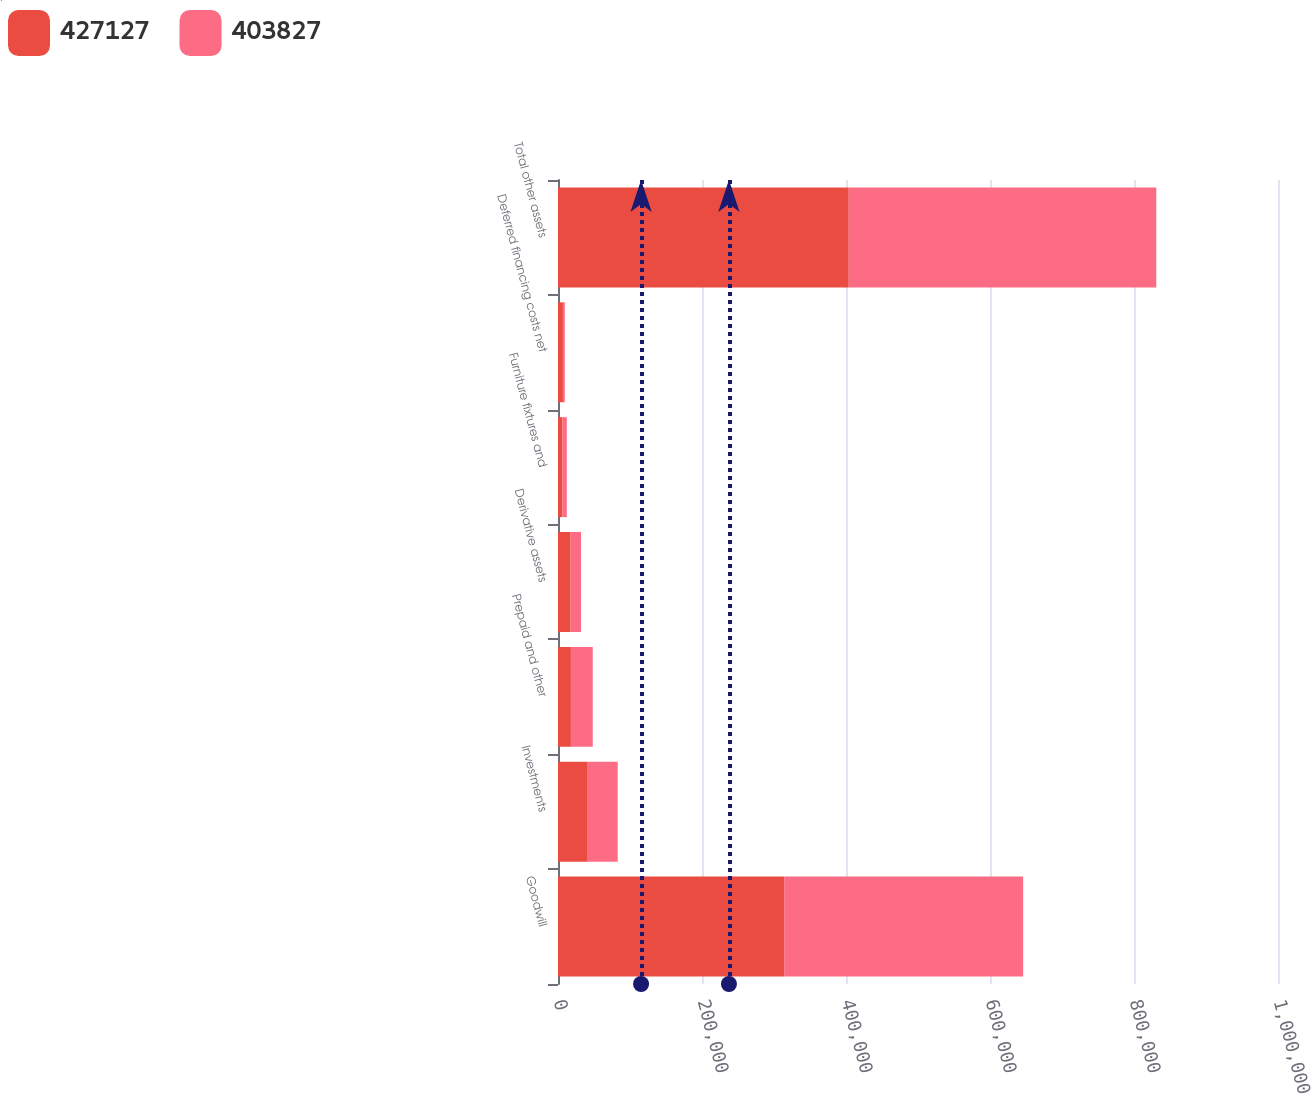Convert chart. <chart><loc_0><loc_0><loc_500><loc_500><stacked_bar_chart><ecel><fcel>Goodwill<fcel>Investments<fcel>Prepaid and other<fcel>Derivative assets<fcel>Furniture fixtures and<fcel>Deferred financing costs net<fcel>Total other assets<nl><fcel>427127<fcel>314143<fcel>41287<fcel>17937<fcel>17482<fcel>6127<fcel>6851<fcel>403827<nl><fcel>403827<fcel>331884<fcel>41636<fcel>30332<fcel>14515<fcel>6123<fcel>2637<fcel>427127<nl></chart> 